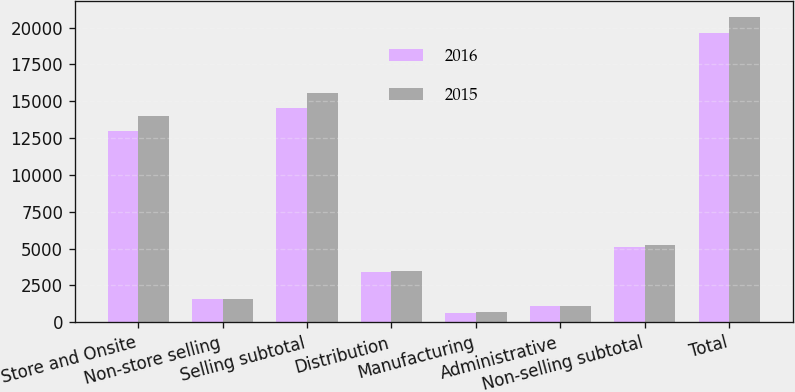Convert chart to OTSL. <chart><loc_0><loc_0><loc_500><loc_500><stacked_bar_chart><ecel><fcel>Store and Onsite<fcel>Non-store selling<fcel>Selling subtotal<fcel>Distribution<fcel>Manufacturing<fcel>Administrative<fcel>Non-selling subtotal<fcel>Total<nl><fcel>2016<fcel>12966<fcel>1575<fcel>14541<fcel>3403<fcel>594<fcel>1086<fcel>5083<fcel>19624<nl><fcel>2015<fcel>13961<fcel>1566<fcel>15527<fcel>3459<fcel>662<fcel>1098<fcel>5219<fcel>20746<nl></chart> 